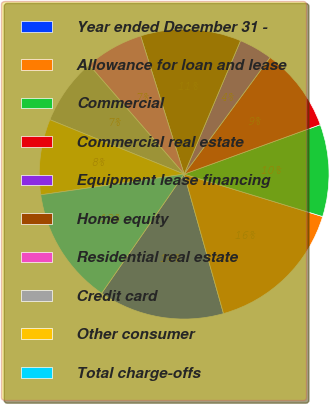<chart> <loc_0><loc_0><loc_500><loc_500><pie_chart><fcel>Year ended December 31 -<fcel>Allowance for loan and lease<fcel>Commercial<fcel>Commercial real estate<fcel>Equipment lease financing<fcel>Home equity<fcel>Residential real estate<fcel>Credit card<fcel>Other consumer<fcel>Total charge-offs<nl><fcel>14.02%<fcel>15.89%<fcel>10.28%<fcel>9.35%<fcel>3.74%<fcel>11.21%<fcel>6.54%<fcel>7.48%<fcel>8.41%<fcel>13.08%<nl></chart> 